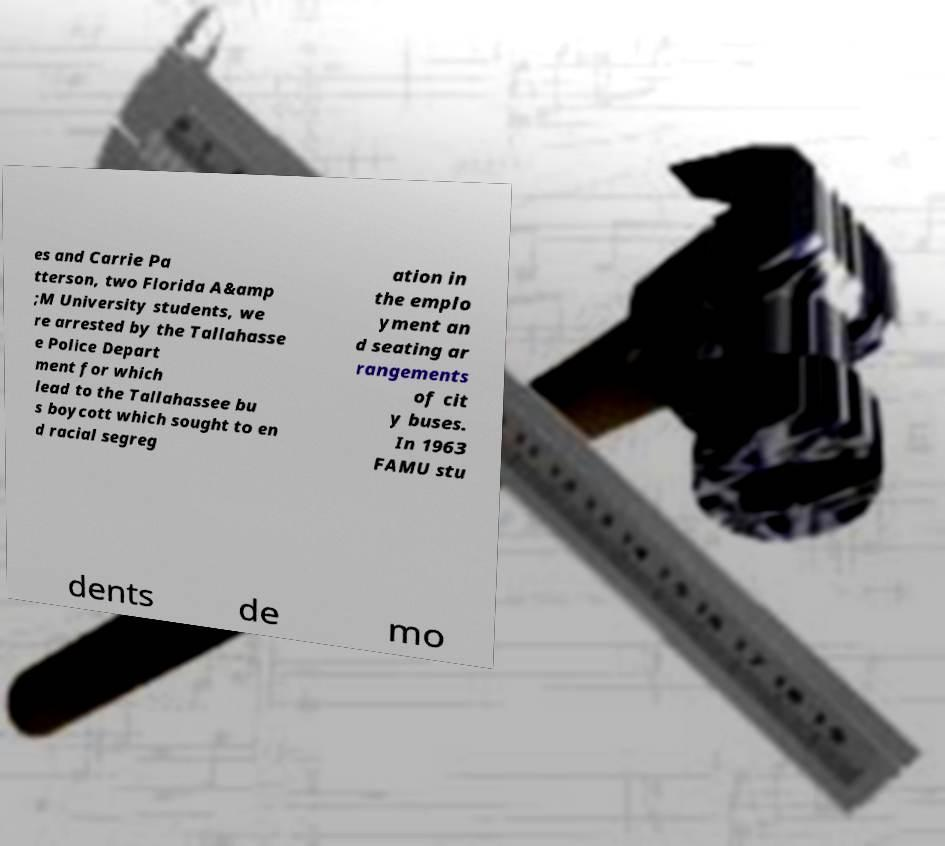There's text embedded in this image that I need extracted. Can you transcribe it verbatim? es and Carrie Pa tterson, two Florida A&amp ;M University students, we re arrested by the Tallahasse e Police Depart ment for which lead to the Tallahassee bu s boycott which sought to en d racial segreg ation in the emplo yment an d seating ar rangements of cit y buses. In 1963 FAMU stu dents de mo 